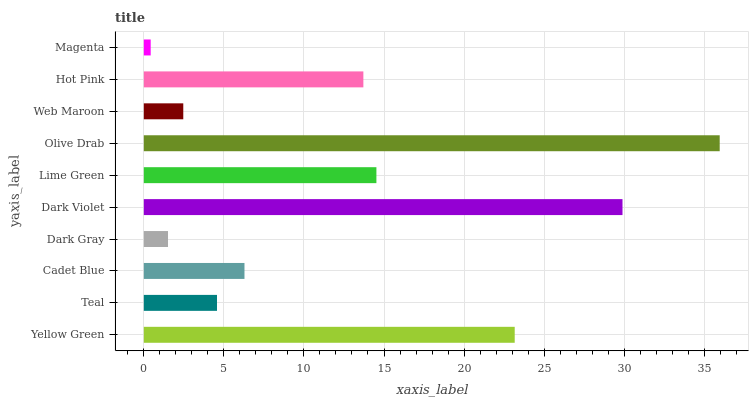Is Magenta the minimum?
Answer yes or no. Yes. Is Olive Drab the maximum?
Answer yes or no. Yes. Is Teal the minimum?
Answer yes or no. No. Is Teal the maximum?
Answer yes or no. No. Is Yellow Green greater than Teal?
Answer yes or no. Yes. Is Teal less than Yellow Green?
Answer yes or no. Yes. Is Teal greater than Yellow Green?
Answer yes or no. No. Is Yellow Green less than Teal?
Answer yes or no. No. Is Hot Pink the high median?
Answer yes or no. Yes. Is Cadet Blue the low median?
Answer yes or no. Yes. Is Teal the high median?
Answer yes or no. No. Is Hot Pink the low median?
Answer yes or no. No. 